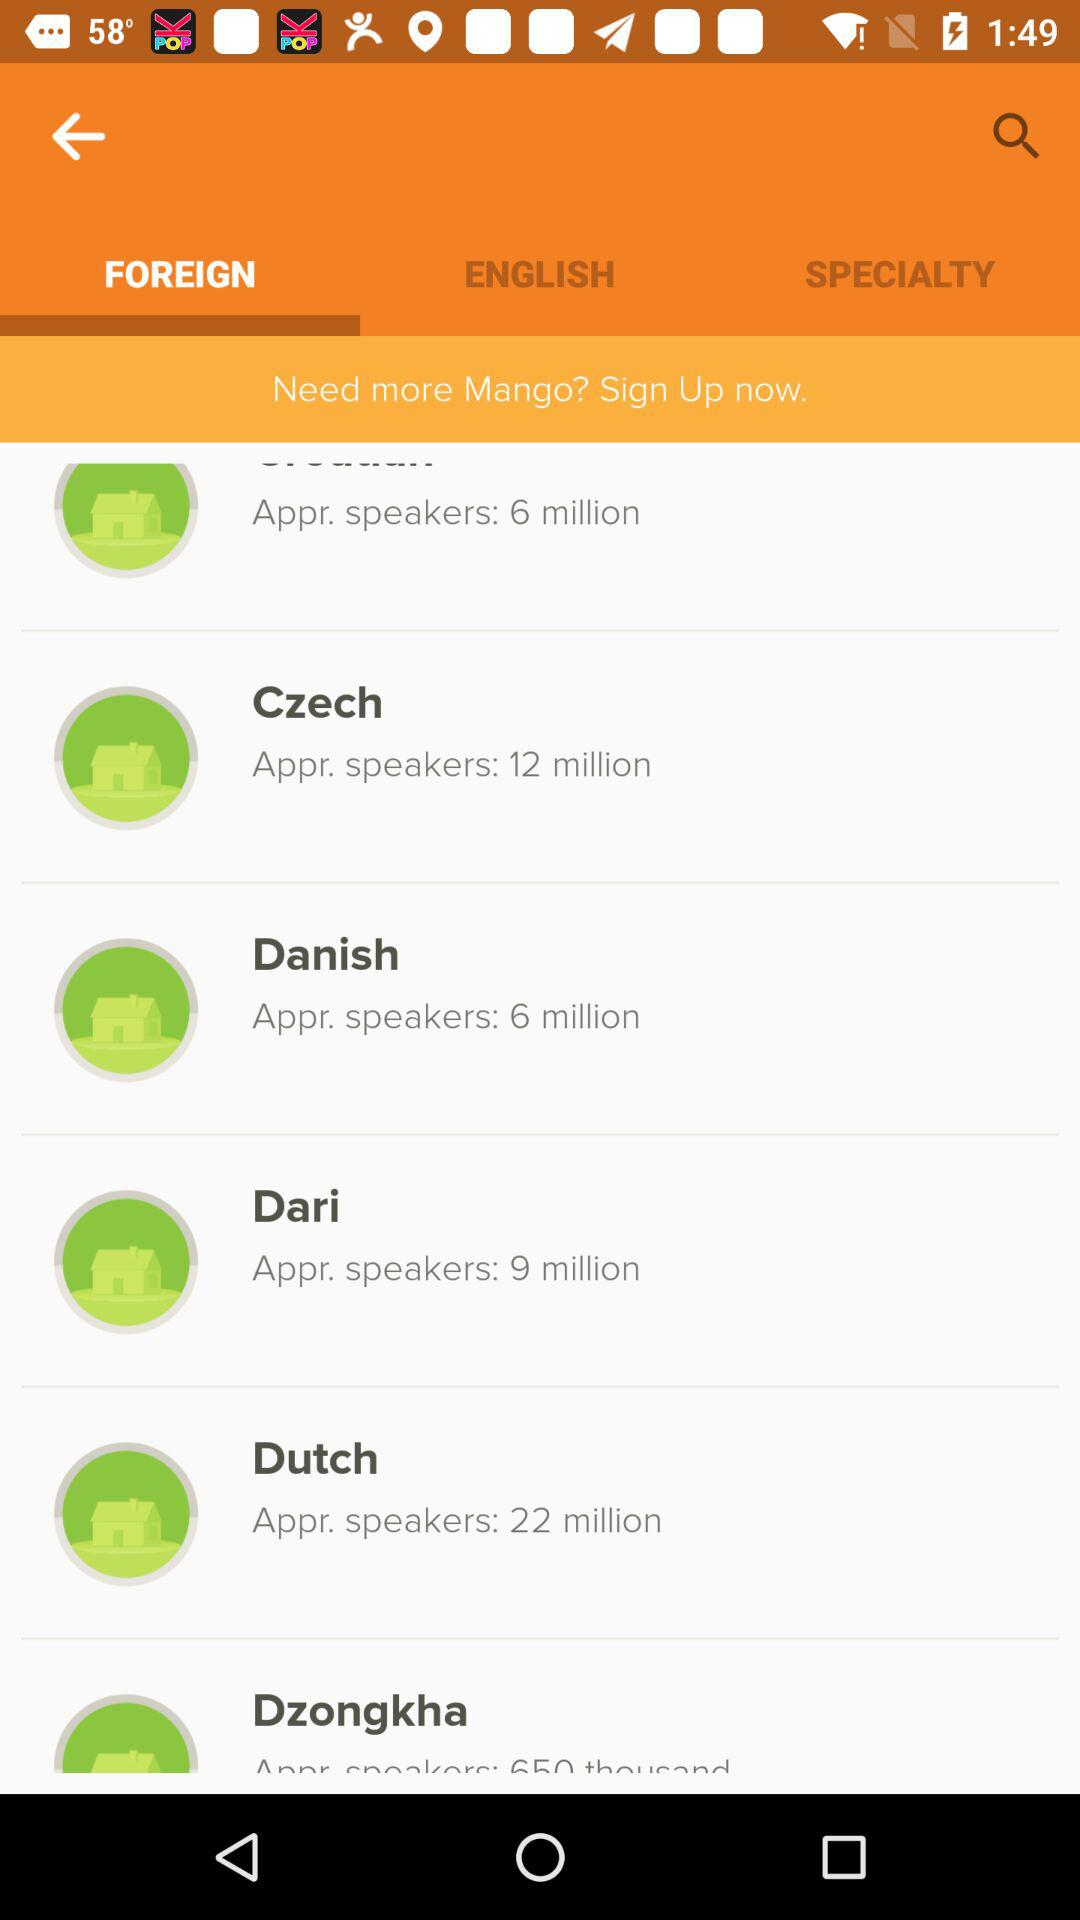How many Dutch speakers are there? There are approximately 22 million Dutch speakers. 